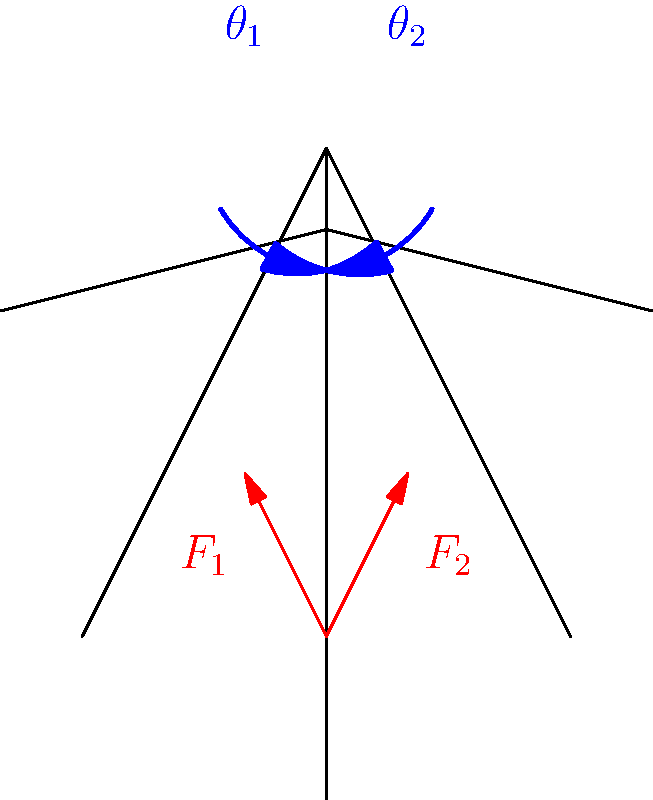During a squat exercise, your friend Richard Shultz wants to know how the joint angles at the hip and knee affect the forces on the legs. If the hip angle ($\theta_1$) is 120° and the knee angle ($\theta_2$) is 90°, how would you describe the relationship between these angles and the forces ($F_1$ and $F_2$) acting on the legs? To understand the relationship between joint angles and forces during a squat, let's break it down step-by-step:

1. Joint angles:
   - Hip angle ($\theta_1$) = 120°
   - Knee angle ($\theta_2$) = 90°

2. Force distribution:
   - $F_1$ represents the force on the quadriceps
   - $F_2$ represents the force on the hamstrings and glutes

3. Angle-force relationship:
   a) As $\theta_1$ increases (hip flexion), $F_2$ increases due to greater tension in the hamstrings and glutes.
   b) As $\theta_2$ decreases (knee flexion), $F_1$ increases due to greater tension in the quadriceps.

4. Moment arm analysis:
   - The moment arm for $F_1$ is at its maximum when $\theta_2$ is 90°, which means the quadriceps are working at their highest efficiency.
   - The moment arm for $F_2$ is relatively large at $\theta_1$ = 120°, indicating significant engagement of the hamstrings and glutes.

5. Force magnitude:
   - With $\theta_1$ at 120° and $\theta_2$ at 90°, both $F_1$ and $F_2$ are relatively high, indicating substantial muscle engagement in both the quadriceps and hamstrings/glutes.

6. Balance and stability:
   - The combination of these angles provides a balanced distribution of forces, promoting stability during the squat.

In this specific squat position, there is a relatively equal distribution of forces between the anterior (quadriceps) and posterior (hamstrings/glutes) muscle groups, promoting an efficient and stable squat movement.
Answer: Balanced force distribution with high engagement of both quadriceps and hamstrings/glutes 